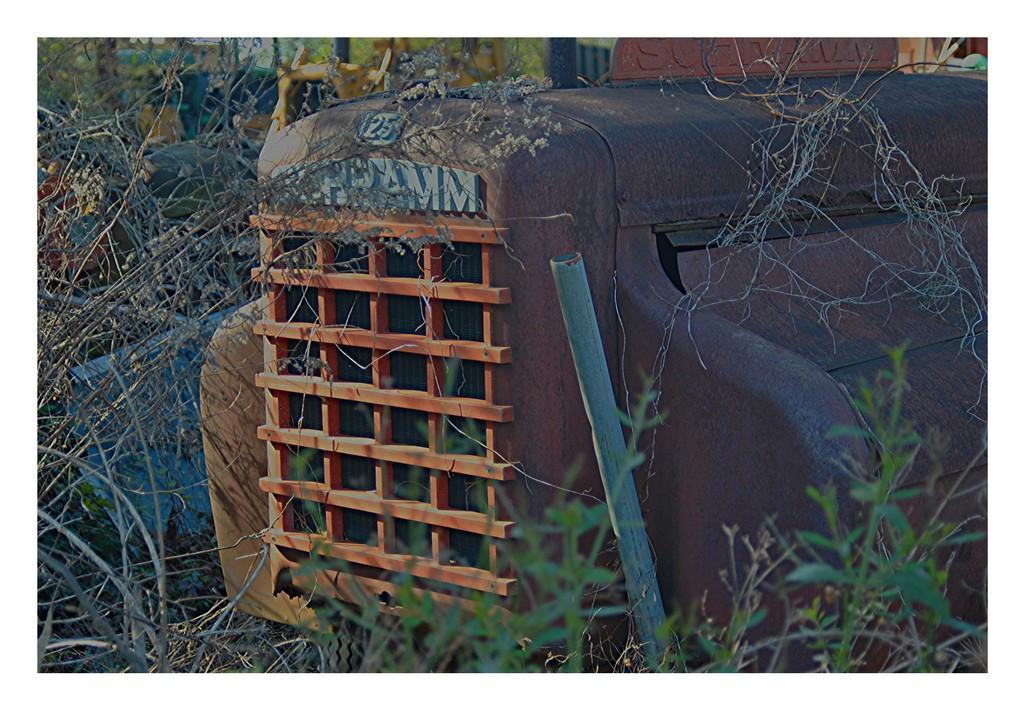Describe this image in one or two sentences. In this picture we can see few plants and few metal things. 